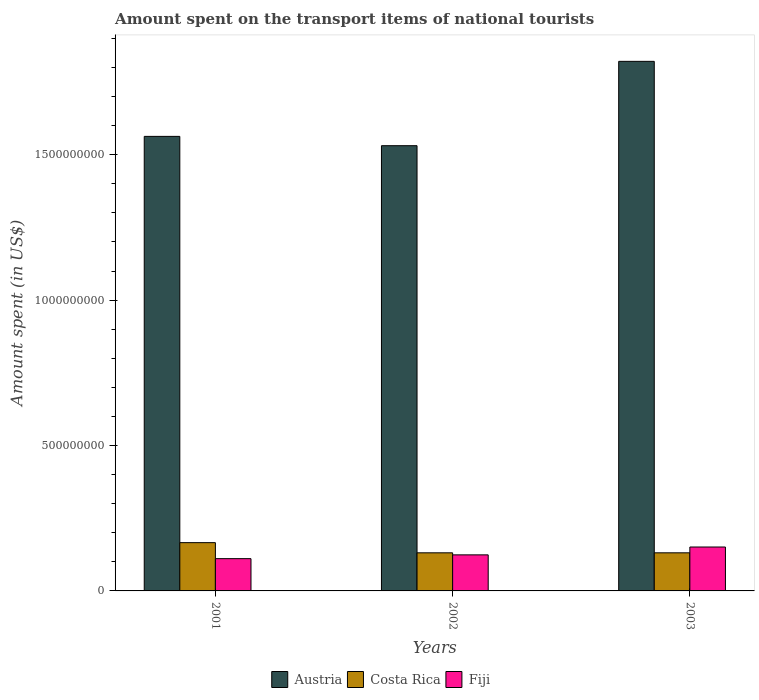How many bars are there on the 1st tick from the left?
Your response must be concise. 3. What is the amount spent on the transport items of national tourists in Costa Rica in 2003?
Your response must be concise. 1.31e+08. Across all years, what is the maximum amount spent on the transport items of national tourists in Austria?
Offer a terse response. 1.82e+09. Across all years, what is the minimum amount spent on the transport items of national tourists in Costa Rica?
Your response must be concise. 1.31e+08. In which year was the amount spent on the transport items of national tourists in Austria maximum?
Keep it short and to the point. 2003. In which year was the amount spent on the transport items of national tourists in Fiji minimum?
Make the answer very short. 2001. What is the total amount spent on the transport items of national tourists in Costa Rica in the graph?
Make the answer very short. 4.28e+08. What is the difference between the amount spent on the transport items of national tourists in Austria in 2002 and that in 2003?
Offer a very short reply. -2.90e+08. What is the difference between the amount spent on the transport items of national tourists in Costa Rica in 2001 and the amount spent on the transport items of national tourists in Fiji in 2002?
Your answer should be very brief. 4.20e+07. What is the average amount spent on the transport items of national tourists in Fiji per year?
Offer a very short reply. 1.29e+08. In the year 2002, what is the difference between the amount spent on the transport items of national tourists in Costa Rica and amount spent on the transport items of national tourists in Fiji?
Offer a very short reply. 7.00e+06. What is the ratio of the amount spent on the transport items of national tourists in Austria in 2001 to that in 2003?
Your response must be concise. 0.86. Is the difference between the amount spent on the transport items of national tourists in Costa Rica in 2001 and 2003 greater than the difference between the amount spent on the transport items of national tourists in Fiji in 2001 and 2003?
Your answer should be very brief. Yes. What is the difference between the highest and the second highest amount spent on the transport items of national tourists in Austria?
Give a very brief answer. 2.58e+08. What is the difference between the highest and the lowest amount spent on the transport items of national tourists in Fiji?
Your answer should be compact. 4.00e+07. In how many years, is the amount spent on the transport items of national tourists in Fiji greater than the average amount spent on the transport items of national tourists in Fiji taken over all years?
Your response must be concise. 1. Is the sum of the amount spent on the transport items of national tourists in Costa Rica in 2001 and 2002 greater than the maximum amount spent on the transport items of national tourists in Fiji across all years?
Offer a terse response. Yes. What does the 1st bar from the right in 2003 represents?
Ensure brevity in your answer.  Fiji. How many bars are there?
Your response must be concise. 9. How many years are there in the graph?
Make the answer very short. 3. Does the graph contain any zero values?
Keep it short and to the point. No. How are the legend labels stacked?
Offer a terse response. Horizontal. What is the title of the graph?
Give a very brief answer. Amount spent on the transport items of national tourists. What is the label or title of the X-axis?
Make the answer very short. Years. What is the label or title of the Y-axis?
Offer a terse response. Amount spent (in US$). What is the Amount spent (in US$) in Austria in 2001?
Your answer should be very brief. 1.56e+09. What is the Amount spent (in US$) of Costa Rica in 2001?
Make the answer very short. 1.66e+08. What is the Amount spent (in US$) of Fiji in 2001?
Provide a succinct answer. 1.11e+08. What is the Amount spent (in US$) in Austria in 2002?
Give a very brief answer. 1.53e+09. What is the Amount spent (in US$) of Costa Rica in 2002?
Offer a terse response. 1.31e+08. What is the Amount spent (in US$) of Fiji in 2002?
Your answer should be very brief. 1.24e+08. What is the Amount spent (in US$) in Austria in 2003?
Keep it short and to the point. 1.82e+09. What is the Amount spent (in US$) of Costa Rica in 2003?
Your answer should be very brief. 1.31e+08. What is the Amount spent (in US$) of Fiji in 2003?
Keep it short and to the point. 1.51e+08. Across all years, what is the maximum Amount spent (in US$) of Austria?
Give a very brief answer. 1.82e+09. Across all years, what is the maximum Amount spent (in US$) in Costa Rica?
Provide a short and direct response. 1.66e+08. Across all years, what is the maximum Amount spent (in US$) in Fiji?
Ensure brevity in your answer.  1.51e+08. Across all years, what is the minimum Amount spent (in US$) of Austria?
Your answer should be very brief. 1.53e+09. Across all years, what is the minimum Amount spent (in US$) in Costa Rica?
Your answer should be compact. 1.31e+08. Across all years, what is the minimum Amount spent (in US$) of Fiji?
Keep it short and to the point. 1.11e+08. What is the total Amount spent (in US$) of Austria in the graph?
Your response must be concise. 4.92e+09. What is the total Amount spent (in US$) of Costa Rica in the graph?
Make the answer very short. 4.28e+08. What is the total Amount spent (in US$) in Fiji in the graph?
Provide a succinct answer. 3.86e+08. What is the difference between the Amount spent (in US$) of Austria in 2001 and that in 2002?
Provide a succinct answer. 3.20e+07. What is the difference between the Amount spent (in US$) of Costa Rica in 2001 and that in 2002?
Your response must be concise. 3.50e+07. What is the difference between the Amount spent (in US$) in Fiji in 2001 and that in 2002?
Offer a terse response. -1.30e+07. What is the difference between the Amount spent (in US$) of Austria in 2001 and that in 2003?
Your answer should be compact. -2.58e+08. What is the difference between the Amount spent (in US$) of Costa Rica in 2001 and that in 2003?
Your answer should be compact. 3.50e+07. What is the difference between the Amount spent (in US$) of Fiji in 2001 and that in 2003?
Provide a short and direct response. -4.00e+07. What is the difference between the Amount spent (in US$) in Austria in 2002 and that in 2003?
Make the answer very short. -2.90e+08. What is the difference between the Amount spent (in US$) of Fiji in 2002 and that in 2003?
Provide a succinct answer. -2.70e+07. What is the difference between the Amount spent (in US$) in Austria in 2001 and the Amount spent (in US$) in Costa Rica in 2002?
Ensure brevity in your answer.  1.43e+09. What is the difference between the Amount spent (in US$) in Austria in 2001 and the Amount spent (in US$) in Fiji in 2002?
Offer a terse response. 1.44e+09. What is the difference between the Amount spent (in US$) in Costa Rica in 2001 and the Amount spent (in US$) in Fiji in 2002?
Offer a very short reply. 4.20e+07. What is the difference between the Amount spent (in US$) in Austria in 2001 and the Amount spent (in US$) in Costa Rica in 2003?
Your answer should be very brief. 1.43e+09. What is the difference between the Amount spent (in US$) of Austria in 2001 and the Amount spent (in US$) of Fiji in 2003?
Provide a succinct answer. 1.41e+09. What is the difference between the Amount spent (in US$) in Costa Rica in 2001 and the Amount spent (in US$) in Fiji in 2003?
Ensure brevity in your answer.  1.50e+07. What is the difference between the Amount spent (in US$) in Austria in 2002 and the Amount spent (in US$) in Costa Rica in 2003?
Your answer should be compact. 1.40e+09. What is the difference between the Amount spent (in US$) in Austria in 2002 and the Amount spent (in US$) in Fiji in 2003?
Keep it short and to the point. 1.38e+09. What is the difference between the Amount spent (in US$) of Costa Rica in 2002 and the Amount spent (in US$) of Fiji in 2003?
Offer a very short reply. -2.00e+07. What is the average Amount spent (in US$) of Austria per year?
Give a very brief answer. 1.64e+09. What is the average Amount spent (in US$) in Costa Rica per year?
Give a very brief answer. 1.43e+08. What is the average Amount spent (in US$) of Fiji per year?
Give a very brief answer. 1.29e+08. In the year 2001, what is the difference between the Amount spent (in US$) of Austria and Amount spent (in US$) of Costa Rica?
Keep it short and to the point. 1.40e+09. In the year 2001, what is the difference between the Amount spent (in US$) of Austria and Amount spent (in US$) of Fiji?
Give a very brief answer. 1.45e+09. In the year 2001, what is the difference between the Amount spent (in US$) in Costa Rica and Amount spent (in US$) in Fiji?
Your answer should be very brief. 5.50e+07. In the year 2002, what is the difference between the Amount spent (in US$) in Austria and Amount spent (in US$) in Costa Rica?
Your answer should be compact. 1.40e+09. In the year 2002, what is the difference between the Amount spent (in US$) in Austria and Amount spent (in US$) in Fiji?
Your answer should be compact. 1.41e+09. In the year 2002, what is the difference between the Amount spent (in US$) of Costa Rica and Amount spent (in US$) of Fiji?
Keep it short and to the point. 7.00e+06. In the year 2003, what is the difference between the Amount spent (in US$) of Austria and Amount spent (in US$) of Costa Rica?
Keep it short and to the point. 1.69e+09. In the year 2003, what is the difference between the Amount spent (in US$) in Austria and Amount spent (in US$) in Fiji?
Provide a succinct answer. 1.67e+09. In the year 2003, what is the difference between the Amount spent (in US$) in Costa Rica and Amount spent (in US$) in Fiji?
Offer a terse response. -2.00e+07. What is the ratio of the Amount spent (in US$) in Austria in 2001 to that in 2002?
Provide a succinct answer. 1.02. What is the ratio of the Amount spent (in US$) of Costa Rica in 2001 to that in 2002?
Your response must be concise. 1.27. What is the ratio of the Amount spent (in US$) of Fiji in 2001 to that in 2002?
Offer a very short reply. 0.9. What is the ratio of the Amount spent (in US$) in Austria in 2001 to that in 2003?
Provide a short and direct response. 0.86. What is the ratio of the Amount spent (in US$) of Costa Rica in 2001 to that in 2003?
Your answer should be very brief. 1.27. What is the ratio of the Amount spent (in US$) of Fiji in 2001 to that in 2003?
Provide a short and direct response. 0.74. What is the ratio of the Amount spent (in US$) of Austria in 2002 to that in 2003?
Provide a succinct answer. 0.84. What is the ratio of the Amount spent (in US$) of Costa Rica in 2002 to that in 2003?
Your answer should be compact. 1. What is the ratio of the Amount spent (in US$) of Fiji in 2002 to that in 2003?
Provide a short and direct response. 0.82. What is the difference between the highest and the second highest Amount spent (in US$) of Austria?
Provide a succinct answer. 2.58e+08. What is the difference between the highest and the second highest Amount spent (in US$) in Costa Rica?
Offer a terse response. 3.50e+07. What is the difference between the highest and the second highest Amount spent (in US$) of Fiji?
Give a very brief answer. 2.70e+07. What is the difference between the highest and the lowest Amount spent (in US$) in Austria?
Make the answer very short. 2.90e+08. What is the difference between the highest and the lowest Amount spent (in US$) of Costa Rica?
Make the answer very short. 3.50e+07. What is the difference between the highest and the lowest Amount spent (in US$) of Fiji?
Make the answer very short. 4.00e+07. 